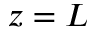<formula> <loc_0><loc_0><loc_500><loc_500>z = L</formula> 